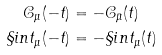<formula> <loc_0><loc_0><loc_500><loc_500>\mathcal { C } _ { \mu } ( - t ) & = - \mathcal { C } _ { \bar { \mu } } ( t ) \\ \S i n t _ { \mu } ( - t ) & = - \S i n t _ { \mu } ( t )</formula> 